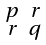<formula> <loc_0><loc_0><loc_500><loc_500>\begin{smallmatrix} p & r \\ r & q \end{smallmatrix}</formula> 